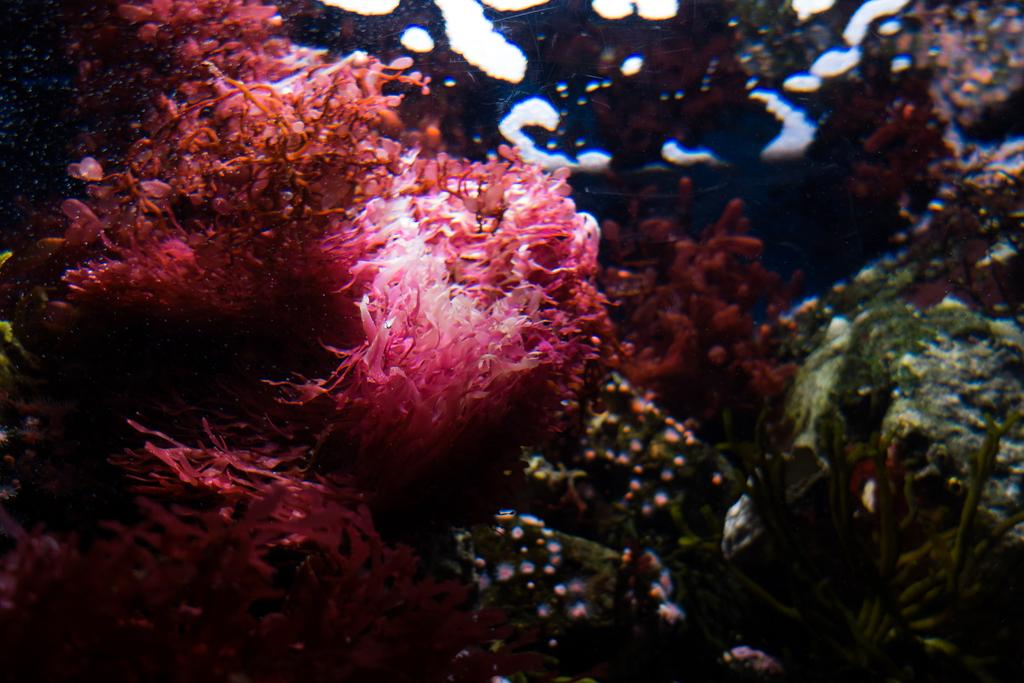What type of environment is shown in the image? The image depicts an underwater scene. What can be seen in the underwater environment? There are corals visible in the image. What type of flowers can be seen growing on the corals in the image? There are no flowers present in the image, as it depicts an underwater scene with corals. 